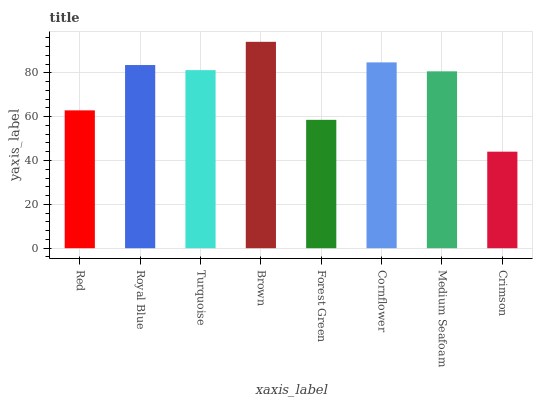Is Crimson the minimum?
Answer yes or no. Yes. Is Brown the maximum?
Answer yes or no. Yes. Is Royal Blue the minimum?
Answer yes or no. No. Is Royal Blue the maximum?
Answer yes or no. No. Is Royal Blue greater than Red?
Answer yes or no. Yes. Is Red less than Royal Blue?
Answer yes or no. Yes. Is Red greater than Royal Blue?
Answer yes or no. No. Is Royal Blue less than Red?
Answer yes or no. No. Is Turquoise the high median?
Answer yes or no. Yes. Is Medium Seafoam the low median?
Answer yes or no. Yes. Is Brown the high median?
Answer yes or no. No. Is Crimson the low median?
Answer yes or no. No. 